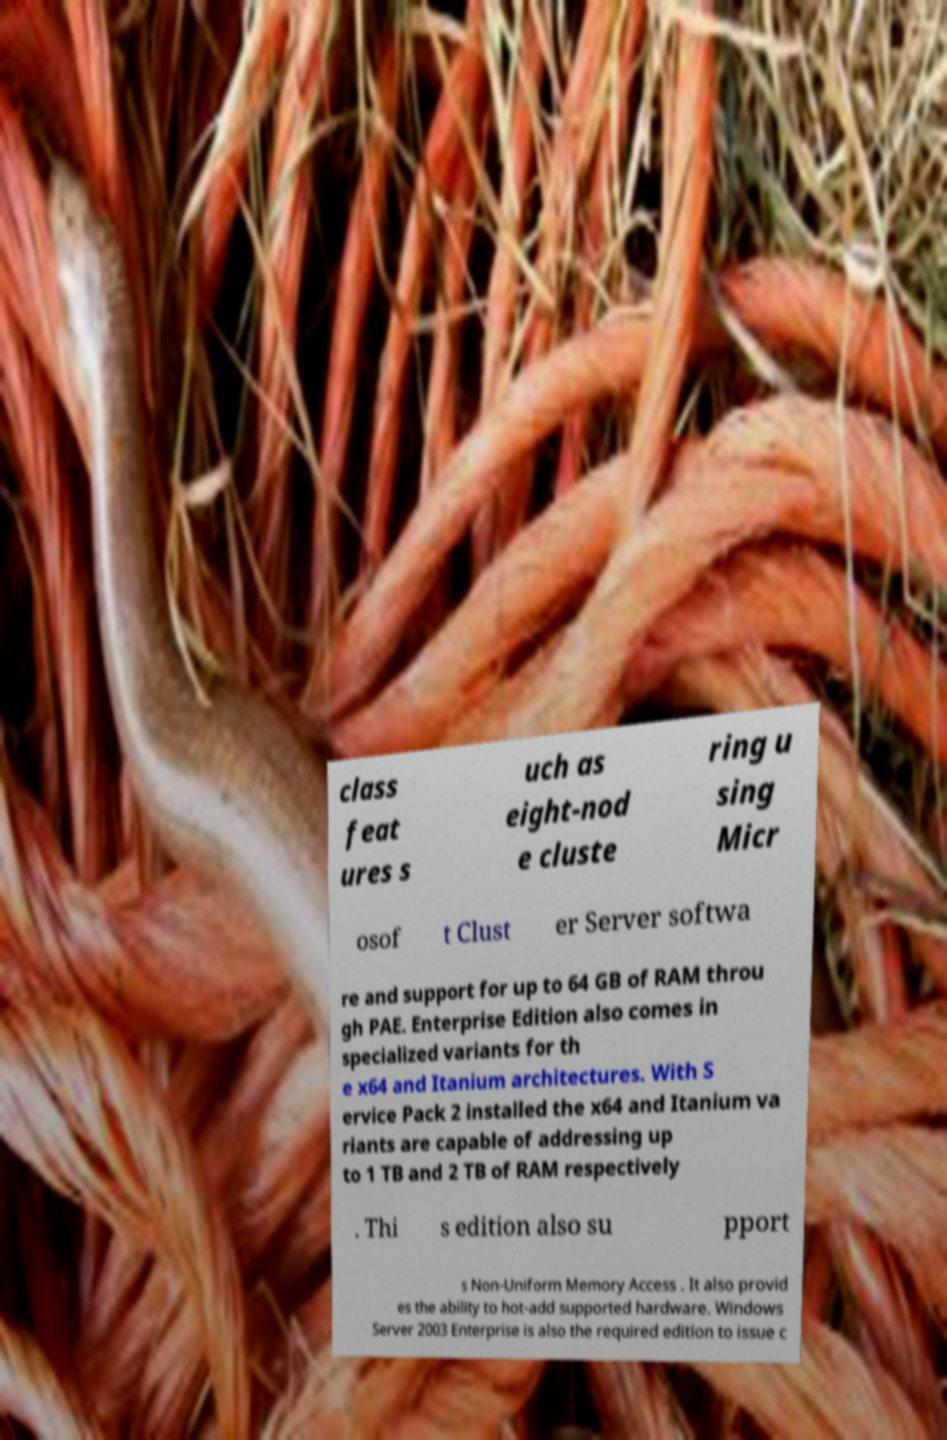Please identify and transcribe the text found in this image. class feat ures s uch as eight-nod e cluste ring u sing Micr osof t Clust er Server softwa re and support for up to 64 GB of RAM throu gh PAE. Enterprise Edition also comes in specialized variants for th e x64 and Itanium architectures. With S ervice Pack 2 installed the x64 and Itanium va riants are capable of addressing up to 1 TB and 2 TB of RAM respectively . Thi s edition also su pport s Non-Uniform Memory Access . It also provid es the ability to hot-add supported hardware. Windows Server 2003 Enterprise is also the required edition to issue c 